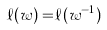<formula> <loc_0><loc_0><loc_500><loc_500>\ell ( w ) = & \ell ( w ^ { - 1 } )</formula> 